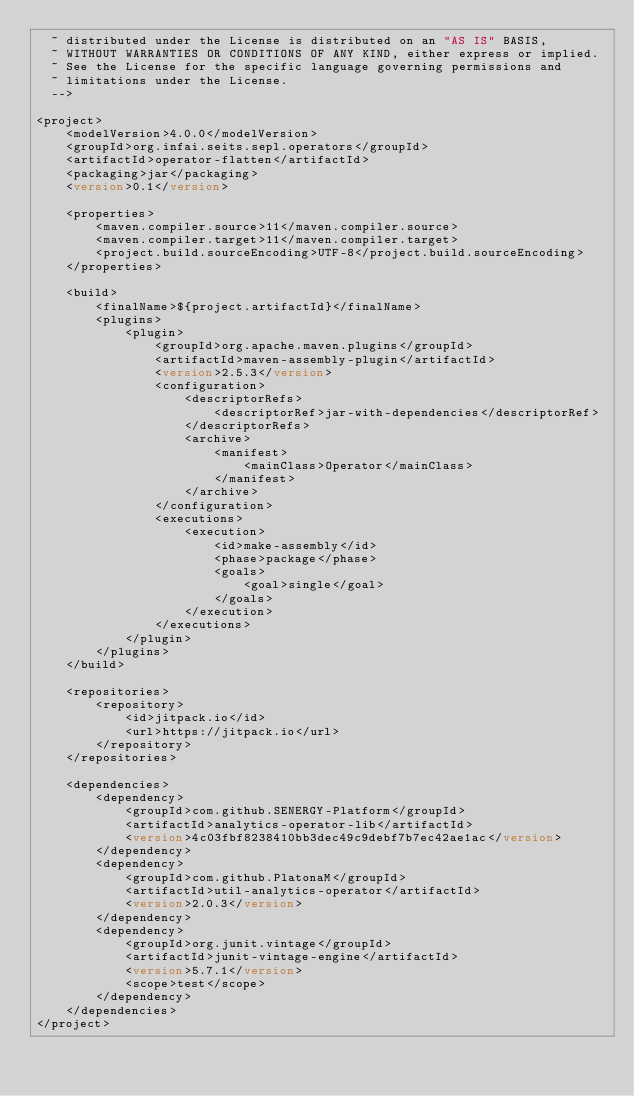<code> <loc_0><loc_0><loc_500><loc_500><_XML_>  ~ distributed under the License is distributed on an "AS IS" BASIS,
  ~ WITHOUT WARRANTIES OR CONDITIONS OF ANY KIND, either express or implied.
  ~ See the License for the specific language governing permissions and
  ~ limitations under the License.
  -->

<project>
    <modelVersion>4.0.0</modelVersion>
    <groupId>org.infai.seits.sepl.operators</groupId>
    <artifactId>operator-flatten</artifactId>
    <packaging>jar</packaging>
    <version>0.1</version>

    <properties>
        <maven.compiler.source>11</maven.compiler.source>
        <maven.compiler.target>11</maven.compiler.target>
        <project.build.sourceEncoding>UTF-8</project.build.sourceEncoding>
    </properties>

    <build>
        <finalName>${project.artifactId}</finalName>
        <plugins>
            <plugin>
                <groupId>org.apache.maven.plugins</groupId>
                <artifactId>maven-assembly-plugin</artifactId>
                <version>2.5.3</version>
                <configuration>
                    <descriptorRefs>
                        <descriptorRef>jar-with-dependencies</descriptorRef>
                    </descriptorRefs>
                    <archive>
                        <manifest>
                            <mainClass>Operator</mainClass>
                        </manifest>
                    </archive>
                </configuration>
                <executions>
                    <execution>
                        <id>make-assembly</id>
                        <phase>package</phase>
                        <goals>
                            <goal>single</goal>
                        </goals>
                    </execution>
                </executions>
            </plugin>
        </plugins>
    </build>

    <repositories>
        <repository>
            <id>jitpack.io</id>
            <url>https://jitpack.io</url>
        </repository>
    </repositories>

    <dependencies>
        <dependency>
            <groupId>com.github.SENERGY-Platform</groupId>
            <artifactId>analytics-operator-lib</artifactId>
            <version>4c03fbf8238410bb3dec49c9debf7b7ec42ae1ac</version>
        </dependency>
        <dependency>
            <groupId>com.github.PlatonaM</groupId>
            <artifactId>util-analytics-operator</artifactId>
            <version>2.0.3</version>
        </dependency>
        <dependency>
            <groupId>org.junit.vintage</groupId>
            <artifactId>junit-vintage-engine</artifactId>
            <version>5.7.1</version>
            <scope>test</scope>
        </dependency>
    </dependencies>
</project>
</code> 